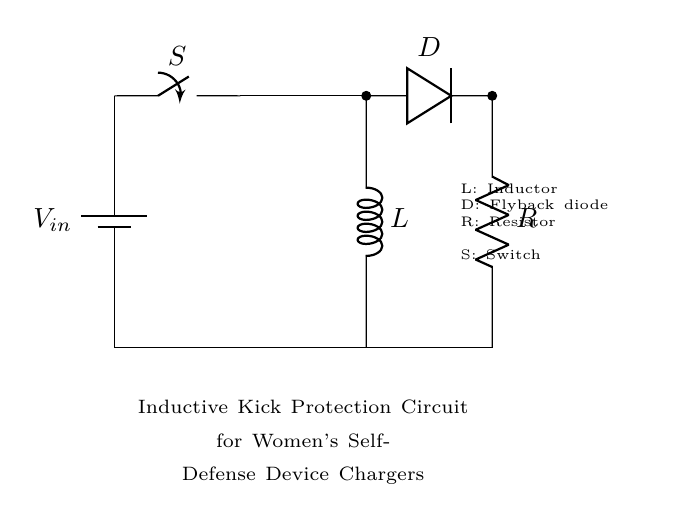What is the voltage source in this circuit? The voltage source is labeled as V_in and positioned at the top left corner, indicating the starting potential for the circuit.
Answer: V_in What does the switch do in this circuit? The switch (labeled S) connects or disconnects the circuit by allowing or breaking the current flow to the components below it.
Answer: Connects or disconnects What component is used for inductive kick protection? The inductor (labeled L) is the primary component for storing energy and providing inductive kick protection by opposing sudden changes in current.
Answer: Inductor How many components are in series in this circuit? The components in series consist of the switch, inductor, diode, and resistor, totaling four components connected one after another in the same path.
Answer: Four What is the purpose of the flyback diode in this circuit? The flyback diode (labeled D) is installed to allow current to bypass the inductor when the switch is opened, preventing voltage spikes that could damage other components.
Answer: Prevents voltage spikes What happens when the switch is open? When the switch is open, the circuit is incomplete, so no current flows through the inductor, and the battery cannot charge the circuit components.
Answer: No current flows What is the role of the resistor in this circuit? The resistor (labeled R) limits current flow through the circuit, ensuring that the devices operate within their current ratings and protecting them from overheating.
Answer: Limits current flow 